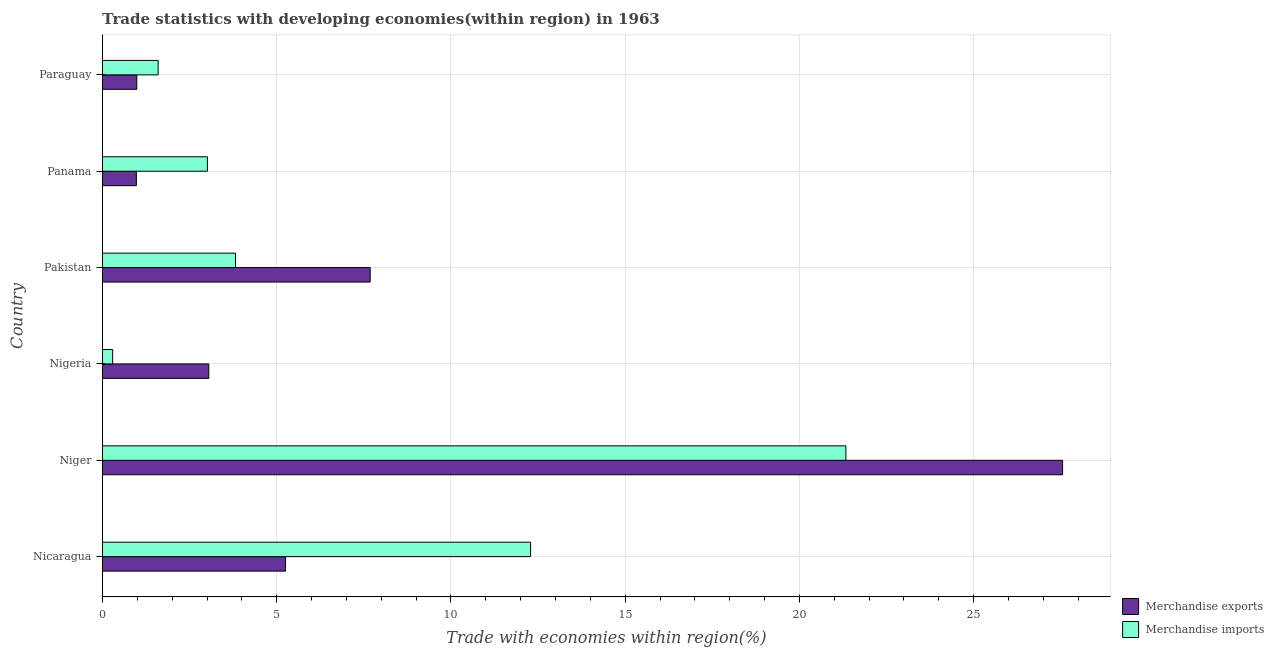Are the number of bars on each tick of the Y-axis equal?
Provide a succinct answer. Yes. What is the label of the 5th group of bars from the top?
Give a very brief answer. Niger. What is the merchandise imports in Panama?
Keep it short and to the point. 3.01. Across all countries, what is the maximum merchandise imports?
Provide a short and direct response. 21.33. Across all countries, what is the minimum merchandise imports?
Keep it short and to the point. 0.29. In which country was the merchandise imports maximum?
Provide a short and direct response. Niger. In which country was the merchandise exports minimum?
Keep it short and to the point. Panama. What is the total merchandise imports in the graph?
Ensure brevity in your answer.  42.34. What is the difference between the merchandise imports in Nicaragua and that in Nigeria?
Your answer should be very brief. 11.99. What is the difference between the merchandise exports in Panama and the merchandise imports in Paraguay?
Keep it short and to the point. -0.62. What is the average merchandise imports per country?
Make the answer very short. 7.06. What is the difference between the merchandise imports and merchandise exports in Pakistan?
Your response must be concise. -3.87. What is the ratio of the merchandise exports in Pakistan to that in Panama?
Provide a short and direct response. 7.89. Is the merchandise exports in Panama less than that in Paraguay?
Ensure brevity in your answer.  Yes. Is the difference between the merchandise exports in Nigeria and Paraguay greater than the difference between the merchandise imports in Nigeria and Paraguay?
Offer a very short reply. Yes. What is the difference between the highest and the second highest merchandise imports?
Your answer should be very brief. 9.05. What is the difference between the highest and the lowest merchandise exports?
Provide a succinct answer. 26.58. How many bars are there?
Make the answer very short. 12. Are all the bars in the graph horizontal?
Provide a short and direct response. Yes. What is the difference between two consecutive major ticks on the X-axis?
Make the answer very short. 5. Does the graph contain any zero values?
Your answer should be very brief. No. Where does the legend appear in the graph?
Give a very brief answer. Bottom right. How many legend labels are there?
Keep it short and to the point. 2. How are the legend labels stacked?
Offer a very short reply. Vertical. What is the title of the graph?
Offer a very short reply. Trade statistics with developing economies(within region) in 1963. What is the label or title of the X-axis?
Your response must be concise. Trade with economies within region(%). What is the Trade with economies within region(%) of Merchandise exports in Nicaragua?
Offer a very short reply. 5.25. What is the Trade with economies within region(%) in Merchandise imports in Nicaragua?
Provide a succinct answer. 12.29. What is the Trade with economies within region(%) of Merchandise exports in Niger?
Offer a very short reply. 27.55. What is the Trade with economies within region(%) of Merchandise imports in Niger?
Ensure brevity in your answer.  21.33. What is the Trade with economies within region(%) of Merchandise exports in Nigeria?
Your answer should be compact. 3.05. What is the Trade with economies within region(%) in Merchandise imports in Nigeria?
Your answer should be compact. 0.29. What is the Trade with economies within region(%) in Merchandise exports in Pakistan?
Provide a short and direct response. 7.68. What is the Trade with economies within region(%) in Merchandise imports in Pakistan?
Make the answer very short. 3.82. What is the Trade with economies within region(%) of Merchandise exports in Panama?
Make the answer very short. 0.97. What is the Trade with economies within region(%) in Merchandise imports in Panama?
Provide a succinct answer. 3.01. What is the Trade with economies within region(%) in Merchandise exports in Paraguay?
Your response must be concise. 0.99. What is the Trade with economies within region(%) of Merchandise imports in Paraguay?
Your answer should be very brief. 1.6. Across all countries, what is the maximum Trade with economies within region(%) of Merchandise exports?
Your response must be concise. 27.55. Across all countries, what is the maximum Trade with economies within region(%) of Merchandise imports?
Offer a very short reply. 21.33. Across all countries, what is the minimum Trade with economies within region(%) in Merchandise exports?
Your answer should be compact. 0.97. Across all countries, what is the minimum Trade with economies within region(%) of Merchandise imports?
Ensure brevity in your answer.  0.29. What is the total Trade with economies within region(%) in Merchandise exports in the graph?
Provide a short and direct response. 45.5. What is the total Trade with economies within region(%) of Merchandise imports in the graph?
Offer a terse response. 42.34. What is the difference between the Trade with economies within region(%) of Merchandise exports in Nicaragua and that in Niger?
Ensure brevity in your answer.  -22.3. What is the difference between the Trade with economies within region(%) in Merchandise imports in Nicaragua and that in Niger?
Offer a terse response. -9.05. What is the difference between the Trade with economies within region(%) of Merchandise exports in Nicaragua and that in Nigeria?
Offer a very short reply. 2.2. What is the difference between the Trade with economies within region(%) in Merchandise imports in Nicaragua and that in Nigeria?
Offer a very short reply. 11.99. What is the difference between the Trade with economies within region(%) of Merchandise exports in Nicaragua and that in Pakistan?
Your answer should be compact. -2.43. What is the difference between the Trade with economies within region(%) of Merchandise imports in Nicaragua and that in Pakistan?
Make the answer very short. 8.47. What is the difference between the Trade with economies within region(%) in Merchandise exports in Nicaragua and that in Panama?
Your response must be concise. 4.28. What is the difference between the Trade with economies within region(%) in Merchandise imports in Nicaragua and that in Panama?
Give a very brief answer. 9.27. What is the difference between the Trade with economies within region(%) in Merchandise exports in Nicaragua and that in Paraguay?
Give a very brief answer. 4.27. What is the difference between the Trade with economies within region(%) in Merchandise imports in Nicaragua and that in Paraguay?
Make the answer very short. 10.69. What is the difference between the Trade with economies within region(%) of Merchandise exports in Niger and that in Nigeria?
Ensure brevity in your answer.  24.5. What is the difference between the Trade with economies within region(%) in Merchandise imports in Niger and that in Nigeria?
Make the answer very short. 21.04. What is the difference between the Trade with economies within region(%) in Merchandise exports in Niger and that in Pakistan?
Give a very brief answer. 19.87. What is the difference between the Trade with economies within region(%) in Merchandise imports in Niger and that in Pakistan?
Make the answer very short. 17.52. What is the difference between the Trade with economies within region(%) of Merchandise exports in Niger and that in Panama?
Your answer should be compact. 26.58. What is the difference between the Trade with economies within region(%) of Merchandise imports in Niger and that in Panama?
Give a very brief answer. 18.32. What is the difference between the Trade with economies within region(%) in Merchandise exports in Niger and that in Paraguay?
Provide a succinct answer. 26.57. What is the difference between the Trade with economies within region(%) in Merchandise imports in Niger and that in Paraguay?
Make the answer very short. 19.74. What is the difference between the Trade with economies within region(%) of Merchandise exports in Nigeria and that in Pakistan?
Provide a short and direct response. -4.63. What is the difference between the Trade with economies within region(%) in Merchandise imports in Nigeria and that in Pakistan?
Provide a succinct answer. -3.52. What is the difference between the Trade with economies within region(%) of Merchandise exports in Nigeria and that in Panama?
Make the answer very short. 2.08. What is the difference between the Trade with economies within region(%) of Merchandise imports in Nigeria and that in Panama?
Ensure brevity in your answer.  -2.72. What is the difference between the Trade with economies within region(%) in Merchandise exports in Nigeria and that in Paraguay?
Your response must be concise. 2.07. What is the difference between the Trade with economies within region(%) in Merchandise imports in Nigeria and that in Paraguay?
Your answer should be very brief. -1.3. What is the difference between the Trade with economies within region(%) in Merchandise exports in Pakistan and that in Panama?
Ensure brevity in your answer.  6.71. What is the difference between the Trade with economies within region(%) in Merchandise imports in Pakistan and that in Panama?
Offer a very short reply. 0.81. What is the difference between the Trade with economies within region(%) of Merchandise exports in Pakistan and that in Paraguay?
Your answer should be compact. 6.7. What is the difference between the Trade with economies within region(%) of Merchandise imports in Pakistan and that in Paraguay?
Your answer should be very brief. 2.22. What is the difference between the Trade with economies within region(%) of Merchandise exports in Panama and that in Paraguay?
Keep it short and to the point. -0.01. What is the difference between the Trade with economies within region(%) in Merchandise imports in Panama and that in Paraguay?
Ensure brevity in your answer.  1.41. What is the difference between the Trade with economies within region(%) in Merchandise exports in Nicaragua and the Trade with economies within region(%) in Merchandise imports in Niger?
Your answer should be compact. -16.08. What is the difference between the Trade with economies within region(%) in Merchandise exports in Nicaragua and the Trade with economies within region(%) in Merchandise imports in Nigeria?
Give a very brief answer. 4.96. What is the difference between the Trade with economies within region(%) in Merchandise exports in Nicaragua and the Trade with economies within region(%) in Merchandise imports in Pakistan?
Keep it short and to the point. 1.44. What is the difference between the Trade with economies within region(%) of Merchandise exports in Nicaragua and the Trade with economies within region(%) of Merchandise imports in Panama?
Provide a short and direct response. 2.24. What is the difference between the Trade with economies within region(%) of Merchandise exports in Nicaragua and the Trade with economies within region(%) of Merchandise imports in Paraguay?
Make the answer very short. 3.66. What is the difference between the Trade with economies within region(%) of Merchandise exports in Niger and the Trade with economies within region(%) of Merchandise imports in Nigeria?
Your answer should be very brief. 27.26. What is the difference between the Trade with economies within region(%) in Merchandise exports in Niger and the Trade with economies within region(%) in Merchandise imports in Pakistan?
Your response must be concise. 23.73. What is the difference between the Trade with economies within region(%) of Merchandise exports in Niger and the Trade with economies within region(%) of Merchandise imports in Panama?
Make the answer very short. 24.54. What is the difference between the Trade with economies within region(%) in Merchandise exports in Niger and the Trade with economies within region(%) in Merchandise imports in Paraguay?
Give a very brief answer. 25.95. What is the difference between the Trade with economies within region(%) in Merchandise exports in Nigeria and the Trade with economies within region(%) in Merchandise imports in Pakistan?
Ensure brevity in your answer.  -0.77. What is the difference between the Trade with economies within region(%) in Merchandise exports in Nigeria and the Trade with economies within region(%) in Merchandise imports in Panama?
Offer a very short reply. 0.04. What is the difference between the Trade with economies within region(%) of Merchandise exports in Nigeria and the Trade with economies within region(%) of Merchandise imports in Paraguay?
Your response must be concise. 1.45. What is the difference between the Trade with economies within region(%) in Merchandise exports in Pakistan and the Trade with economies within region(%) in Merchandise imports in Panama?
Your response must be concise. 4.67. What is the difference between the Trade with economies within region(%) in Merchandise exports in Pakistan and the Trade with economies within region(%) in Merchandise imports in Paraguay?
Your answer should be very brief. 6.08. What is the difference between the Trade with economies within region(%) of Merchandise exports in Panama and the Trade with economies within region(%) of Merchandise imports in Paraguay?
Provide a succinct answer. -0.62. What is the average Trade with economies within region(%) in Merchandise exports per country?
Keep it short and to the point. 7.58. What is the average Trade with economies within region(%) in Merchandise imports per country?
Provide a succinct answer. 7.06. What is the difference between the Trade with economies within region(%) in Merchandise exports and Trade with economies within region(%) in Merchandise imports in Nicaragua?
Provide a succinct answer. -7.03. What is the difference between the Trade with economies within region(%) in Merchandise exports and Trade with economies within region(%) in Merchandise imports in Niger?
Your answer should be compact. 6.22. What is the difference between the Trade with economies within region(%) of Merchandise exports and Trade with economies within region(%) of Merchandise imports in Nigeria?
Your answer should be very brief. 2.76. What is the difference between the Trade with economies within region(%) of Merchandise exports and Trade with economies within region(%) of Merchandise imports in Pakistan?
Provide a succinct answer. 3.87. What is the difference between the Trade with economies within region(%) in Merchandise exports and Trade with economies within region(%) in Merchandise imports in Panama?
Your answer should be compact. -2.04. What is the difference between the Trade with economies within region(%) in Merchandise exports and Trade with economies within region(%) in Merchandise imports in Paraguay?
Provide a succinct answer. -0.61. What is the ratio of the Trade with economies within region(%) in Merchandise exports in Nicaragua to that in Niger?
Offer a terse response. 0.19. What is the ratio of the Trade with economies within region(%) of Merchandise imports in Nicaragua to that in Niger?
Provide a succinct answer. 0.58. What is the ratio of the Trade with economies within region(%) of Merchandise exports in Nicaragua to that in Nigeria?
Provide a short and direct response. 1.72. What is the ratio of the Trade with economies within region(%) in Merchandise imports in Nicaragua to that in Nigeria?
Offer a terse response. 41.92. What is the ratio of the Trade with economies within region(%) in Merchandise exports in Nicaragua to that in Pakistan?
Your answer should be compact. 0.68. What is the ratio of the Trade with economies within region(%) of Merchandise imports in Nicaragua to that in Pakistan?
Offer a terse response. 3.22. What is the ratio of the Trade with economies within region(%) of Merchandise exports in Nicaragua to that in Panama?
Your response must be concise. 5.4. What is the ratio of the Trade with economies within region(%) in Merchandise imports in Nicaragua to that in Panama?
Your answer should be very brief. 4.08. What is the ratio of the Trade with economies within region(%) of Merchandise exports in Nicaragua to that in Paraguay?
Give a very brief answer. 5.33. What is the ratio of the Trade with economies within region(%) in Merchandise imports in Nicaragua to that in Paraguay?
Ensure brevity in your answer.  7.69. What is the ratio of the Trade with economies within region(%) in Merchandise exports in Niger to that in Nigeria?
Ensure brevity in your answer.  9.03. What is the ratio of the Trade with economies within region(%) in Merchandise imports in Niger to that in Nigeria?
Keep it short and to the point. 72.8. What is the ratio of the Trade with economies within region(%) in Merchandise exports in Niger to that in Pakistan?
Ensure brevity in your answer.  3.59. What is the ratio of the Trade with economies within region(%) in Merchandise imports in Niger to that in Pakistan?
Your answer should be very brief. 5.59. What is the ratio of the Trade with economies within region(%) in Merchandise exports in Niger to that in Panama?
Your answer should be very brief. 28.31. What is the ratio of the Trade with economies within region(%) of Merchandise imports in Niger to that in Panama?
Keep it short and to the point. 7.08. What is the ratio of the Trade with economies within region(%) in Merchandise exports in Niger to that in Paraguay?
Offer a terse response. 27.96. What is the ratio of the Trade with economies within region(%) in Merchandise imports in Niger to that in Paraguay?
Provide a short and direct response. 13.35. What is the ratio of the Trade with economies within region(%) in Merchandise exports in Nigeria to that in Pakistan?
Give a very brief answer. 0.4. What is the ratio of the Trade with economies within region(%) in Merchandise imports in Nigeria to that in Pakistan?
Offer a very short reply. 0.08. What is the ratio of the Trade with economies within region(%) in Merchandise exports in Nigeria to that in Panama?
Your response must be concise. 3.14. What is the ratio of the Trade with economies within region(%) of Merchandise imports in Nigeria to that in Panama?
Your answer should be very brief. 0.1. What is the ratio of the Trade with economies within region(%) in Merchandise exports in Nigeria to that in Paraguay?
Give a very brief answer. 3.1. What is the ratio of the Trade with economies within region(%) of Merchandise imports in Nigeria to that in Paraguay?
Give a very brief answer. 0.18. What is the ratio of the Trade with economies within region(%) of Merchandise exports in Pakistan to that in Panama?
Provide a short and direct response. 7.89. What is the ratio of the Trade with economies within region(%) of Merchandise imports in Pakistan to that in Panama?
Offer a terse response. 1.27. What is the ratio of the Trade with economies within region(%) in Merchandise exports in Pakistan to that in Paraguay?
Keep it short and to the point. 7.8. What is the ratio of the Trade with economies within region(%) of Merchandise imports in Pakistan to that in Paraguay?
Make the answer very short. 2.39. What is the ratio of the Trade with economies within region(%) in Merchandise exports in Panama to that in Paraguay?
Provide a short and direct response. 0.99. What is the ratio of the Trade with economies within region(%) of Merchandise imports in Panama to that in Paraguay?
Provide a short and direct response. 1.88. What is the difference between the highest and the second highest Trade with economies within region(%) in Merchandise exports?
Provide a short and direct response. 19.87. What is the difference between the highest and the second highest Trade with economies within region(%) of Merchandise imports?
Ensure brevity in your answer.  9.05. What is the difference between the highest and the lowest Trade with economies within region(%) in Merchandise exports?
Your response must be concise. 26.58. What is the difference between the highest and the lowest Trade with economies within region(%) in Merchandise imports?
Ensure brevity in your answer.  21.04. 